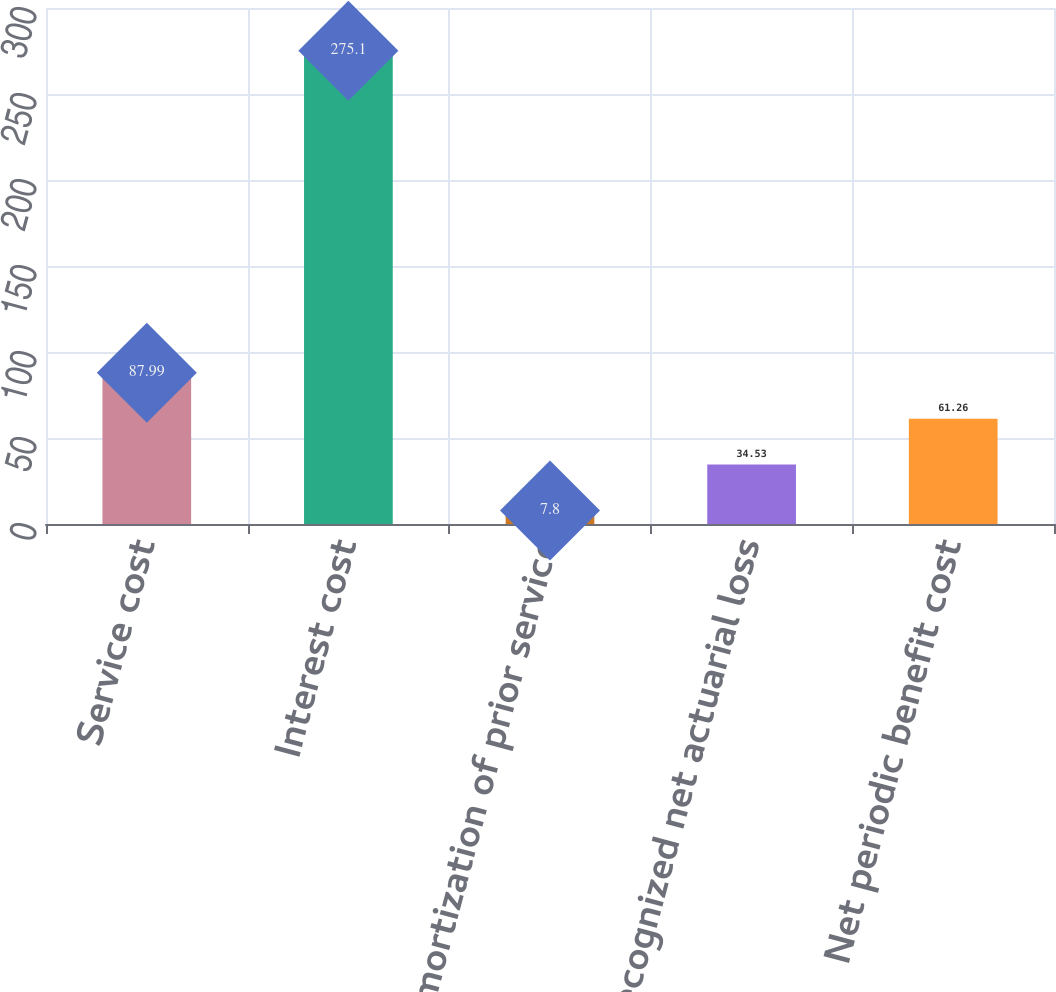Convert chart. <chart><loc_0><loc_0><loc_500><loc_500><bar_chart><fcel>Service cost<fcel>Interest cost<fcel>Amortization of prior service<fcel>Recognized net actuarial loss<fcel>Net periodic benefit cost<nl><fcel>87.99<fcel>275.1<fcel>7.8<fcel>34.53<fcel>61.26<nl></chart> 